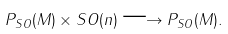<formula> <loc_0><loc_0><loc_500><loc_500>P _ { S O } ( M ) \times S O ( n ) \longrightarrow P _ { S O } ( M ) .</formula> 